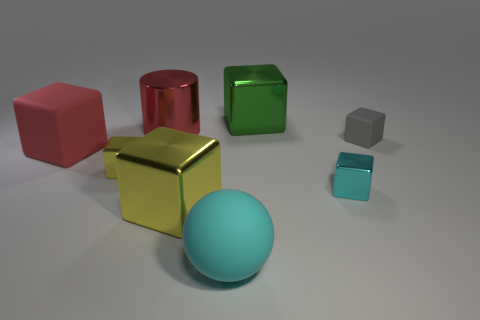What is the color of the large shiny cylinder?
Your response must be concise. Red. There is a red object that is the same material as the sphere; what size is it?
Your answer should be very brief. Large. There is a ball that is made of the same material as the big red block; what color is it?
Ensure brevity in your answer.  Cyan. Is there a red matte thing that has the same size as the cyan cube?
Offer a very short reply. No. What is the material of the green object that is the same shape as the small yellow thing?
Offer a terse response. Metal. There is a yellow metallic thing that is the same size as the green metal cube; what is its shape?
Your answer should be compact. Cube. Is there a large red rubber object of the same shape as the small yellow metal object?
Your answer should be compact. Yes. What is the shape of the yellow object behind the tiny metallic thing in front of the small yellow thing?
Offer a terse response. Cube. There is a green thing; what shape is it?
Ensure brevity in your answer.  Cube. What is the material of the red object in front of the matte cube right of the big rubber object that is behind the big yellow metal thing?
Offer a terse response. Rubber. 